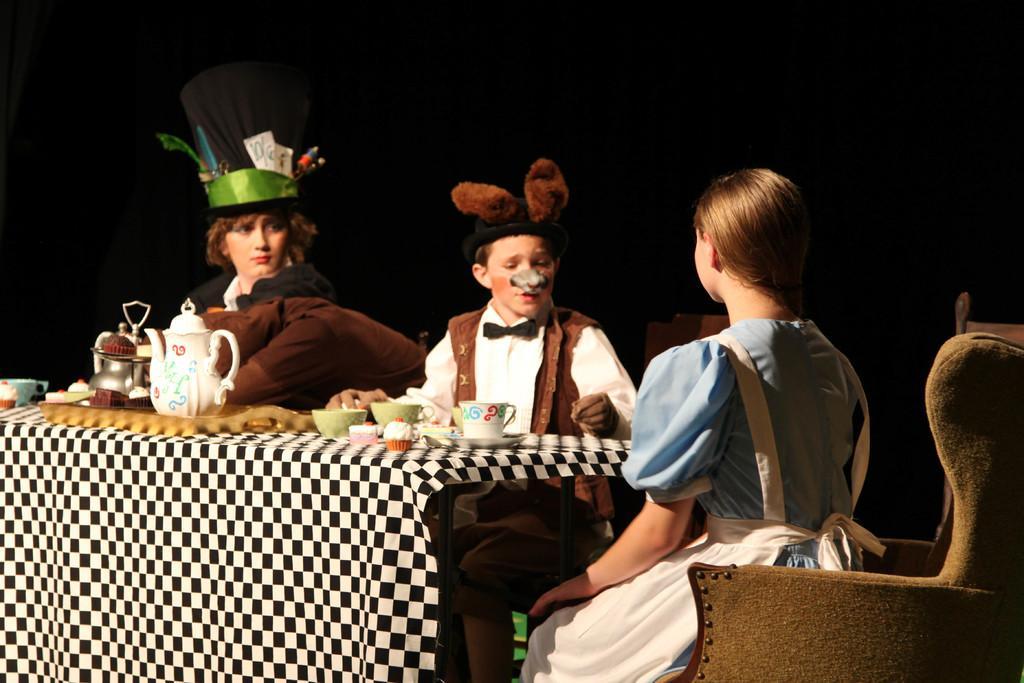Please provide a concise description of this image. In this image we can see four people, they are sitting on the chairs, there is a table in front of them, on that there is a tea pot, cups, cakes, and some other objects, also we can see the background is dark. 